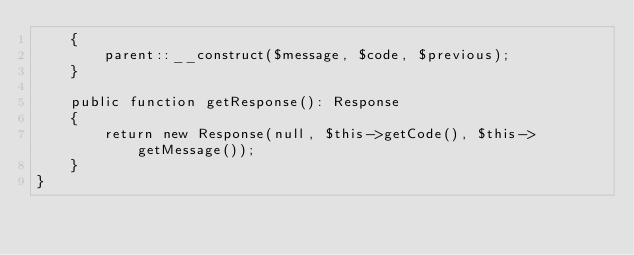<code> <loc_0><loc_0><loc_500><loc_500><_PHP_>    {
        parent::__construct($message, $code, $previous);
    }

    public function getResponse(): Response
    {
        return new Response(null, $this->getCode(), $this->getMessage());
    }
}
</code> 